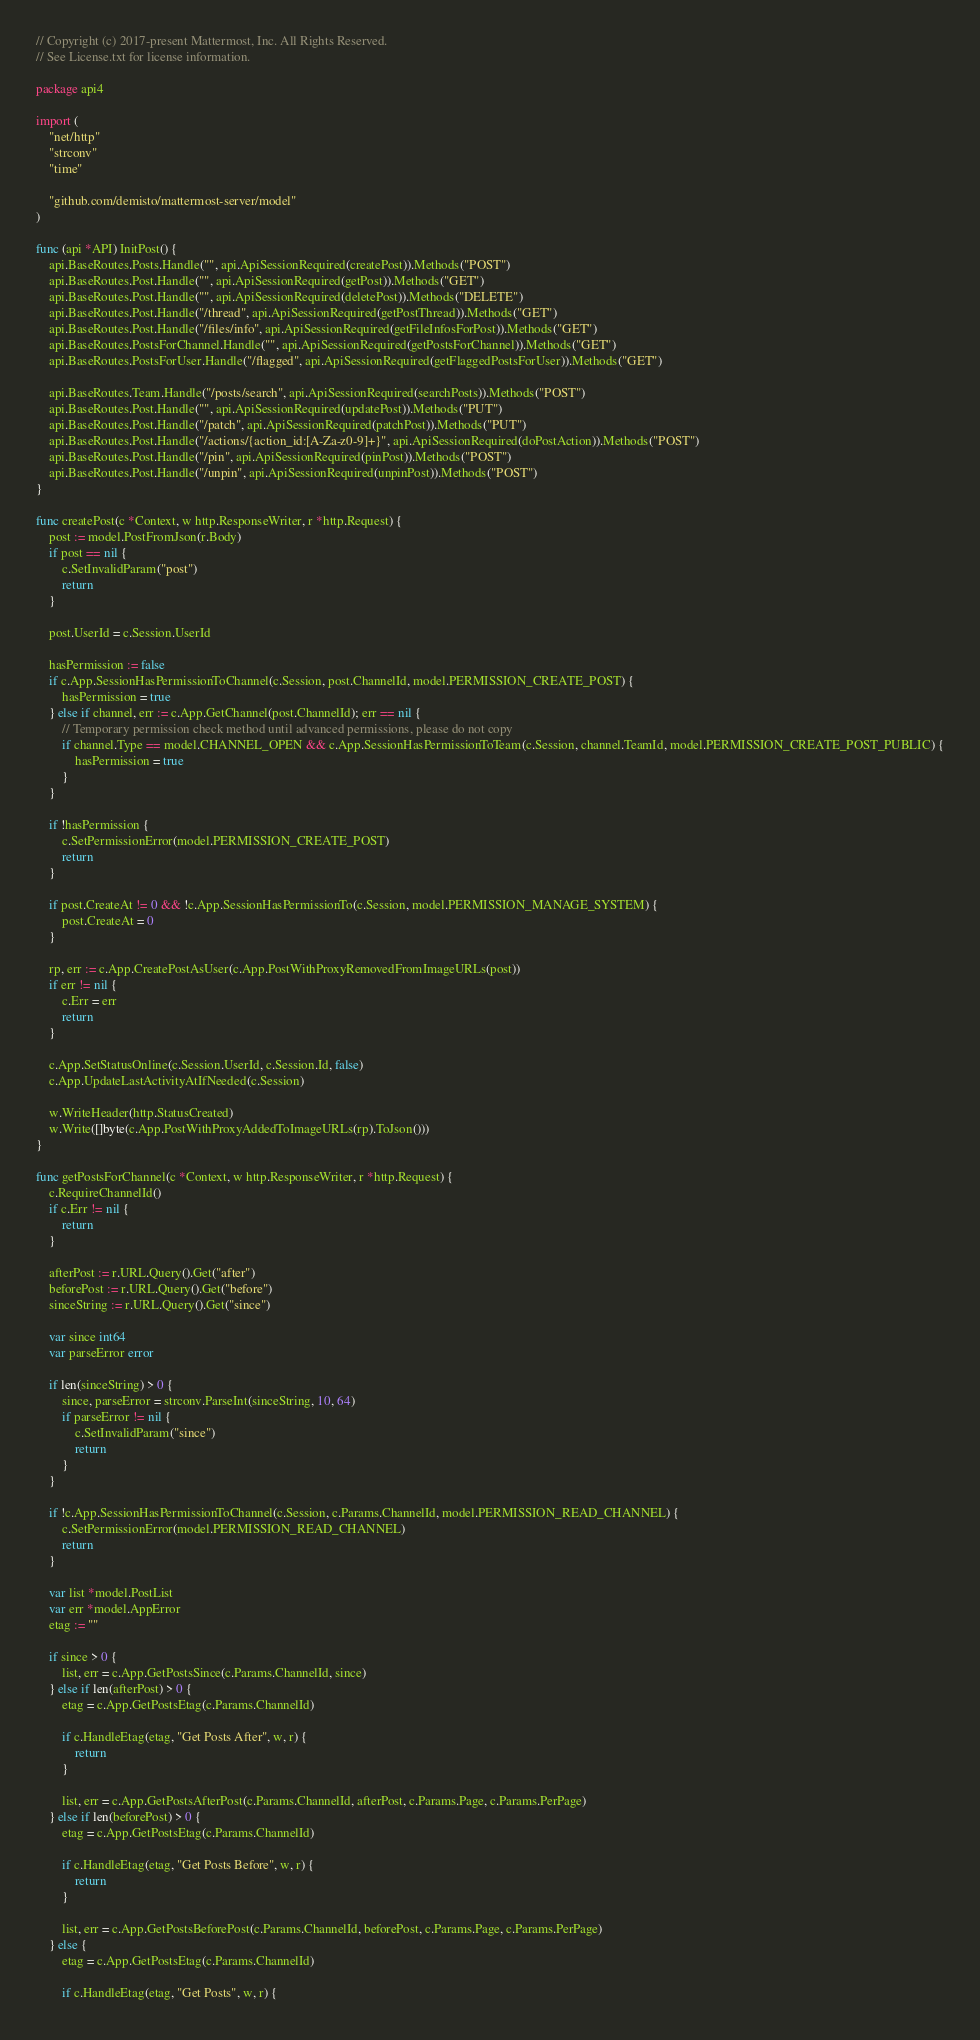<code> <loc_0><loc_0><loc_500><loc_500><_Go_>// Copyright (c) 2017-present Mattermost, Inc. All Rights Reserved.
// See License.txt for license information.

package api4

import (
	"net/http"
	"strconv"
	"time"

	"github.com/demisto/mattermost-server/model"
)

func (api *API) InitPost() {
	api.BaseRoutes.Posts.Handle("", api.ApiSessionRequired(createPost)).Methods("POST")
	api.BaseRoutes.Post.Handle("", api.ApiSessionRequired(getPost)).Methods("GET")
	api.BaseRoutes.Post.Handle("", api.ApiSessionRequired(deletePost)).Methods("DELETE")
	api.BaseRoutes.Post.Handle("/thread", api.ApiSessionRequired(getPostThread)).Methods("GET")
	api.BaseRoutes.Post.Handle("/files/info", api.ApiSessionRequired(getFileInfosForPost)).Methods("GET")
	api.BaseRoutes.PostsForChannel.Handle("", api.ApiSessionRequired(getPostsForChannel)).Methods("GET")
	api.BaseRoutes.PostsForUser.Handle("/flagged", api.ApiSessionRequired(getFlaggedPostsForUser)).Methods("GET")

	api.BaseRoutes.Team.Handle("/posts/search", api.ApiSessionRequired(searchPosts)).Methods("POST")
	api.BaseRoutes.Post.Handle("", api.ApiSessionRequired(updatePost)).Methods("PUT")
	api.BaseRoutes.Post.Handle("/patch", api.ApiSessionRequired(patchPost)).Methods("PUT")
	api.BaseRoutes.Post.Handle("/actions/{action_id:[A-Za-z0-9]+}", api.ApiSessionRequired(doPostAction)).Methods("POST")
	api.BaseRoutes.Post.Handle("/pin", api.ApiSessionRequired(pinPost)).Methods("POST")
	api.BaseRoutes.Post.Handle("/unpin", api.ApiSessionRequired(unpinPost)).Methods("POST")
}

func createPost(c *Context, w http.ResponseWriter, r *http.Request) {
	post := model.PostFromJson(r.Body)
	if post == nil {
		c.SetInvalidParam("post")
		return
	}

	post.UserId = c.Session.UserId

	hasPermission := false
	if c.App.SessionHasPermissionToChannel(c.Session, post.ChannelId, model.PERMISSION_CREATE_POST) {
		hasPermission = true
	} else if channel, err := c.App.GetChannel(post.ChannelId); err == nil {
		// Temporary permission check method until advanced permissions, please do not copy
		if channel.Type == model.CHANNEL_OPEN && c.App.SessionHasPermissionToTeam(c.Session, channel.TeamId, model.PERMISSION_CREATE_POST_PUBLIC) {
			hasPermission = true
		}
	}

	if !hasPermission {
		c.SetPermissionError(model.PERMISSION_CREATE_POST)
		return
	}

	if post.CreateAt != 0 && !c.App.SessionHasPermissionTo(c.Session, model.PERMISSION_MANAGE_SYSTEM) {
		post.CreateAt = 0
	}

	rp, err := c.App.CreatePostAsUser(c.App.PostWithProxyRemovedFromImageURLs(post))
	if err != nil {
		c.Err = err
		return
	}

	c.App.SetStatusOnline(c.Session.UserId, c.Session.Id, false)
	c.App.UpdateLastActivityAtIfNeeded(c.Session)

	w.WriteHeader(http.StatusCreated)
	w.Write([]byte(c.App.PostWithProxyAddedToImageURLs(rp).ToJson()))
}

func getPostsForChannel(c *Context, w http.ResponseWriter, r *http.Request) {
	c.RequireChannelId()
	if c.Err != nil {
		return
	}

	afterPost := r.URL.Query().Get("after")
	beforePost := r.URL.Query().Get("before")
	sinceString := r.URL.Query().Get("since")

	var since int64
	var parseError error

	if len(sinceString) > 0 {
		since, parseError = strconv.ParseInt(sinceString, 10, 64)
		if parseError != nil {
			c.SetInvalidParam("since")
			return
		}
	}

	if !c.App.SessionHasPermissionToChannel(c.Session, c.Params.ChannelId, model.PERMISSION_READ_CHANNEL) {
		c.SetPermissionError(model.PERMISSION_READ_CHANNEL)
		return
	}

	var list *model.PostList
	var err *model.AppError
	etag := ""

	if since > 0 {
		list, err = c.App.GetPostsSince(c.Params.ChannelId, since)
	} else if len(afterPost) > 0 {
		etag = c.App.GetPostsEtag(c.Params.ChannelId)

		if c.HandleEtag(etag, "Get Posts After", w, r) {
			return
		}

		list, err = c.App.GetPostsAfterPost(c.Params.ChannelId, afterPost, c.Params.Page, c.Params.PerPage)
	} else if len(beforePost) > 0 {
		etag = c.App.GetPostsEtag(c.Params.ChannelId)

		if c.HandleEtag(etag, "Get Posts Before", w, r) {
			return
		}

		list, err = c.App.GetPostsBeforePost(c.Params.ChannelId, beforePost, c.Params.Page, c.Params.PerPage)
	} else {
		etag = c.App.GetPostsEtag(c.Params.ChannelId)

		if c.HandleEtag(etag, "Get Posts", w, r) {</code> 